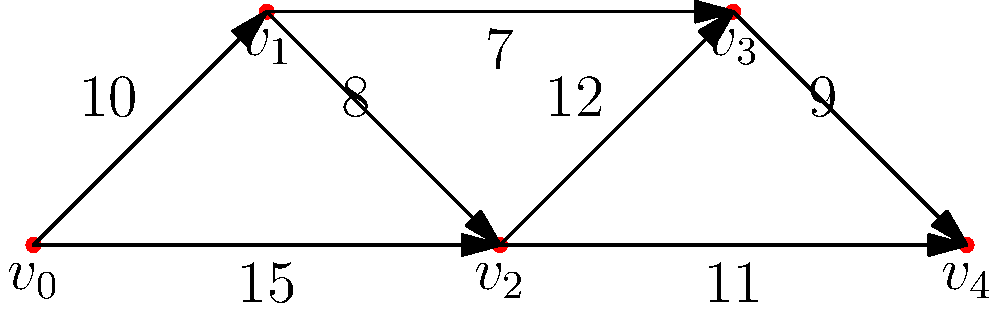The graph represents a network flow model for optimizing ship hull design, where nodes represent different sections of the hull and edges represent water flow paths with their respective capacities (in thousands of liters per second). What is the maximum flow from $v_0$ to $v_4$, and how does this relate to the ship's ability to withstand extreme weather conditions? To find the maximum flow from $v_0$ to $v_4$, we need to use the Ford-Fulkerson algorithm or a similar max-flow algorithm. Let's solve this step-by-step:

1. Identify all possible paths from $v_0$ to $v_4$:
   Path 1: $v_0 \rightarrow v_1 \rightarrow v_2 \rightarrow v_3 \rightarrow v_4$
   Path 2: $v_0 \rightarrow v_1 \rightarrow v_3 \rightarrow v_4$
   Path 3: $v_0 \rightarrow v_2 \rightarrow v_3 \rightarrow v_4$
   Path 4: $v_0 \rightarrow v_2 \rightarrow v_4$

2. Calculate the maximum flow for each path:
   Path 1: $\min(10, 8, 12, 9) = 8$
   Path 2: $\min(10, 7, 9) = 7$
   Path 3: $\min(15, 12, 9) = 9$
   Path 4: $\min(15, 11) = 11$

3. Start with the path of highest capacity (Path 4) and saturate it:
   Flow = 11
   Residual capacities: $v_0 \rightarrow v_2$: 4, $v_2 \rightarrow v_4$: 0

4. Find the next available path (Path 3) and add its flow:
   Additional flow = 9
   Total flow = 11 + 9 = 20
   Residual capacities: $v_0 \rightarrow v_2$: 0, $v_2 \rightarrow v_3$: 3, $v_3 \rightarrow v_4$: 0

5. No more augmenting paths are available, so the maximum flow is 20.

This maximum flow of 20,000 liters per second represents the ship hull's optimal design for water displacement. A higher flow indicates better ability to channel water away from the hull, reducing resistance and improving stability in extreme weather conditions. This design allows the ship to efficiently move through rough seas, minimizing the impact of high waves and strong currents, thus enhancing its ability to withstand extreme weather.
Answer: 20,000 liters per second; higher flow indicates better water displacement and improved stability in extreme weather. 